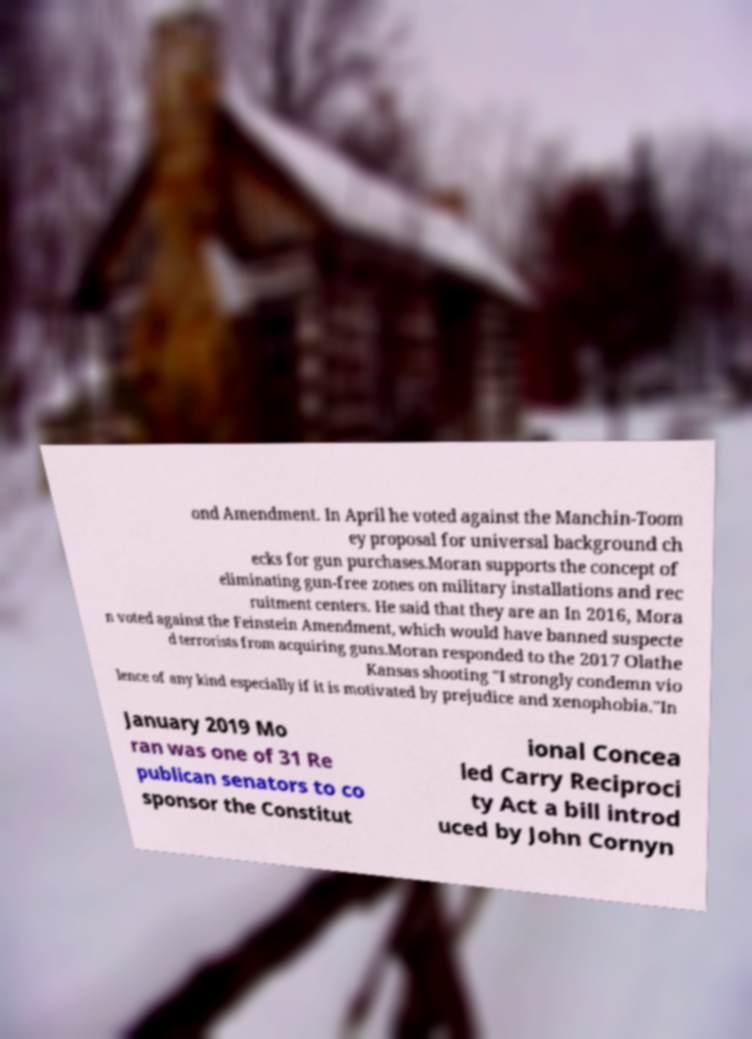Please read and relay the text visible in this image. What does it say? ond Amendment. In April he voted against the Manchin-Toom ey proposal for universal background ch ecks for gun purchases.Moran supports the concept of eliminating gun-free zones on military installations and rec ruitment centers. He said that they are an In 2016, Mora n voted against the Feinstein Amendment, which would have banned suspecte d terrorists from acquiring guns.Moran responded to the 2017 Olathe Kansas shooting "I strongly condemn vio lence of any kind especially if it is motivated by prejudice and xenophobia."In January 2019 Mo ran was one of 31 Re publican senators to co sponsor the Constitut ional Concea led Carry Reciproci ty Act a bill introd uced by John Cornyn 